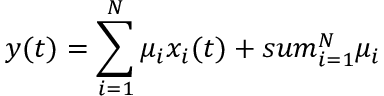Convert formula to latex. <formula><loc_0><loc_0><loc_500><loc_500>y ( t ) = \sum _ { i = 1 } ^ { N } \mu _ { i } x _ { i } ( t ) + s u m _ { i = 1 } ^ { N } \mu _ { i }</formula> 